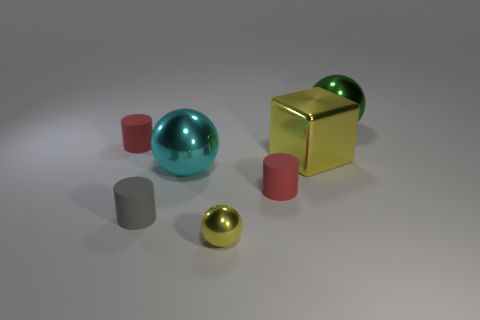Add 2 tiny cylinders. How many objects exist? 9 Subtract all gray cylinders. How many cylinders are left? 2 Subtract all red cylinders. How many cylinders are left? 1 Subtract all cubes. How many objects are left? 6 Subtract 1 cubes. How many cubes are left? 0 Subtract all cyan cylinders. Subtract all yellow blocks. How many cylinders are left? 3 Subtract all green cubes. How many gray cylinders are left? 1 Subtract all tiny matte cylinders. Subtract all yellow metal things. How many objects are left? 2 Add 4 large green things. How many large green things are left? 5 Add 4 purple metal blocks. How many purple metal blocks exist? 4 